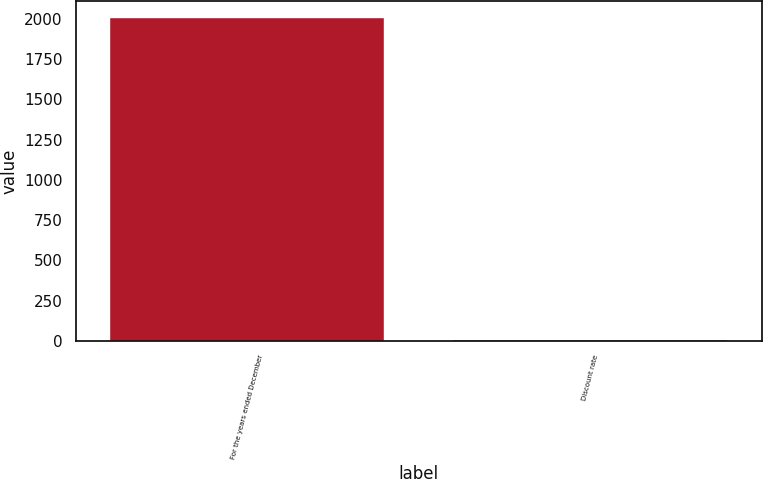<chart> <loc_0><loc_0><loc_500><loc_500><bar_chart><fcel>For the years ended December<fcel>Discount rate<nl><fcel>2009<fcel>6.4<nl></chart> 